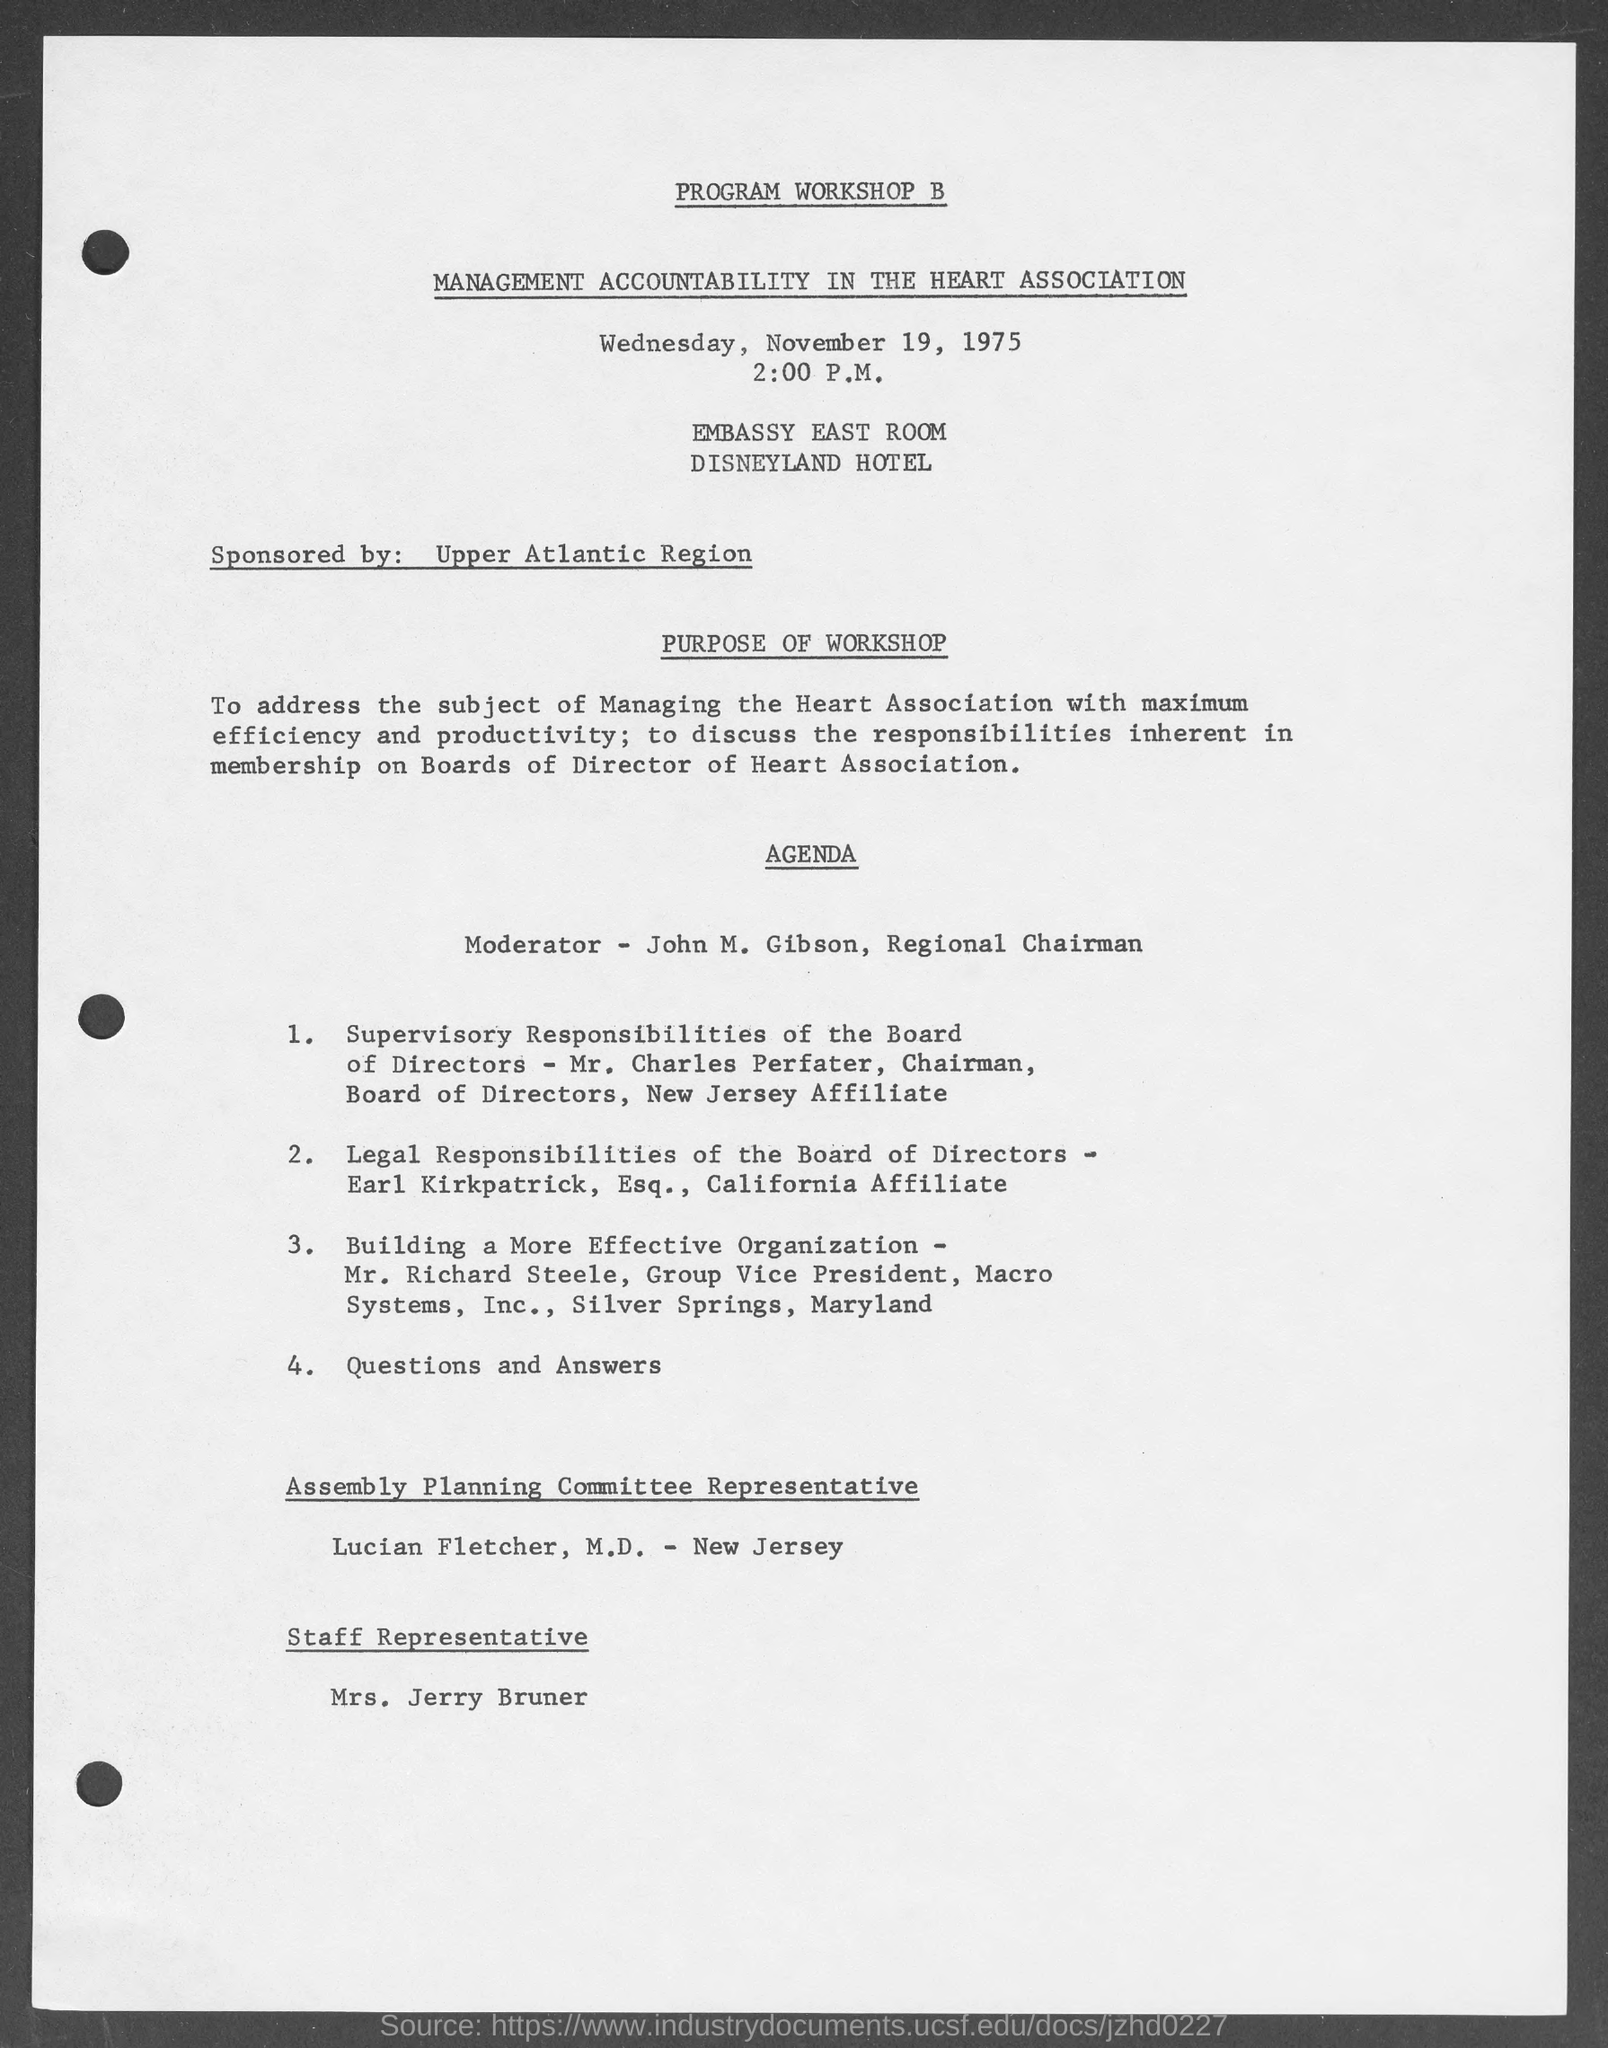List a handful of essential elements in this visual. I declare that the program was sponsored by the Upper Atlantic region. The assembly planning committee representative is Lucian Fletcher, M.D. The document mentions Wednesday. The document mentions that the date is November 19, 1975. The moderator named in the agenda is John M. Gibson. 